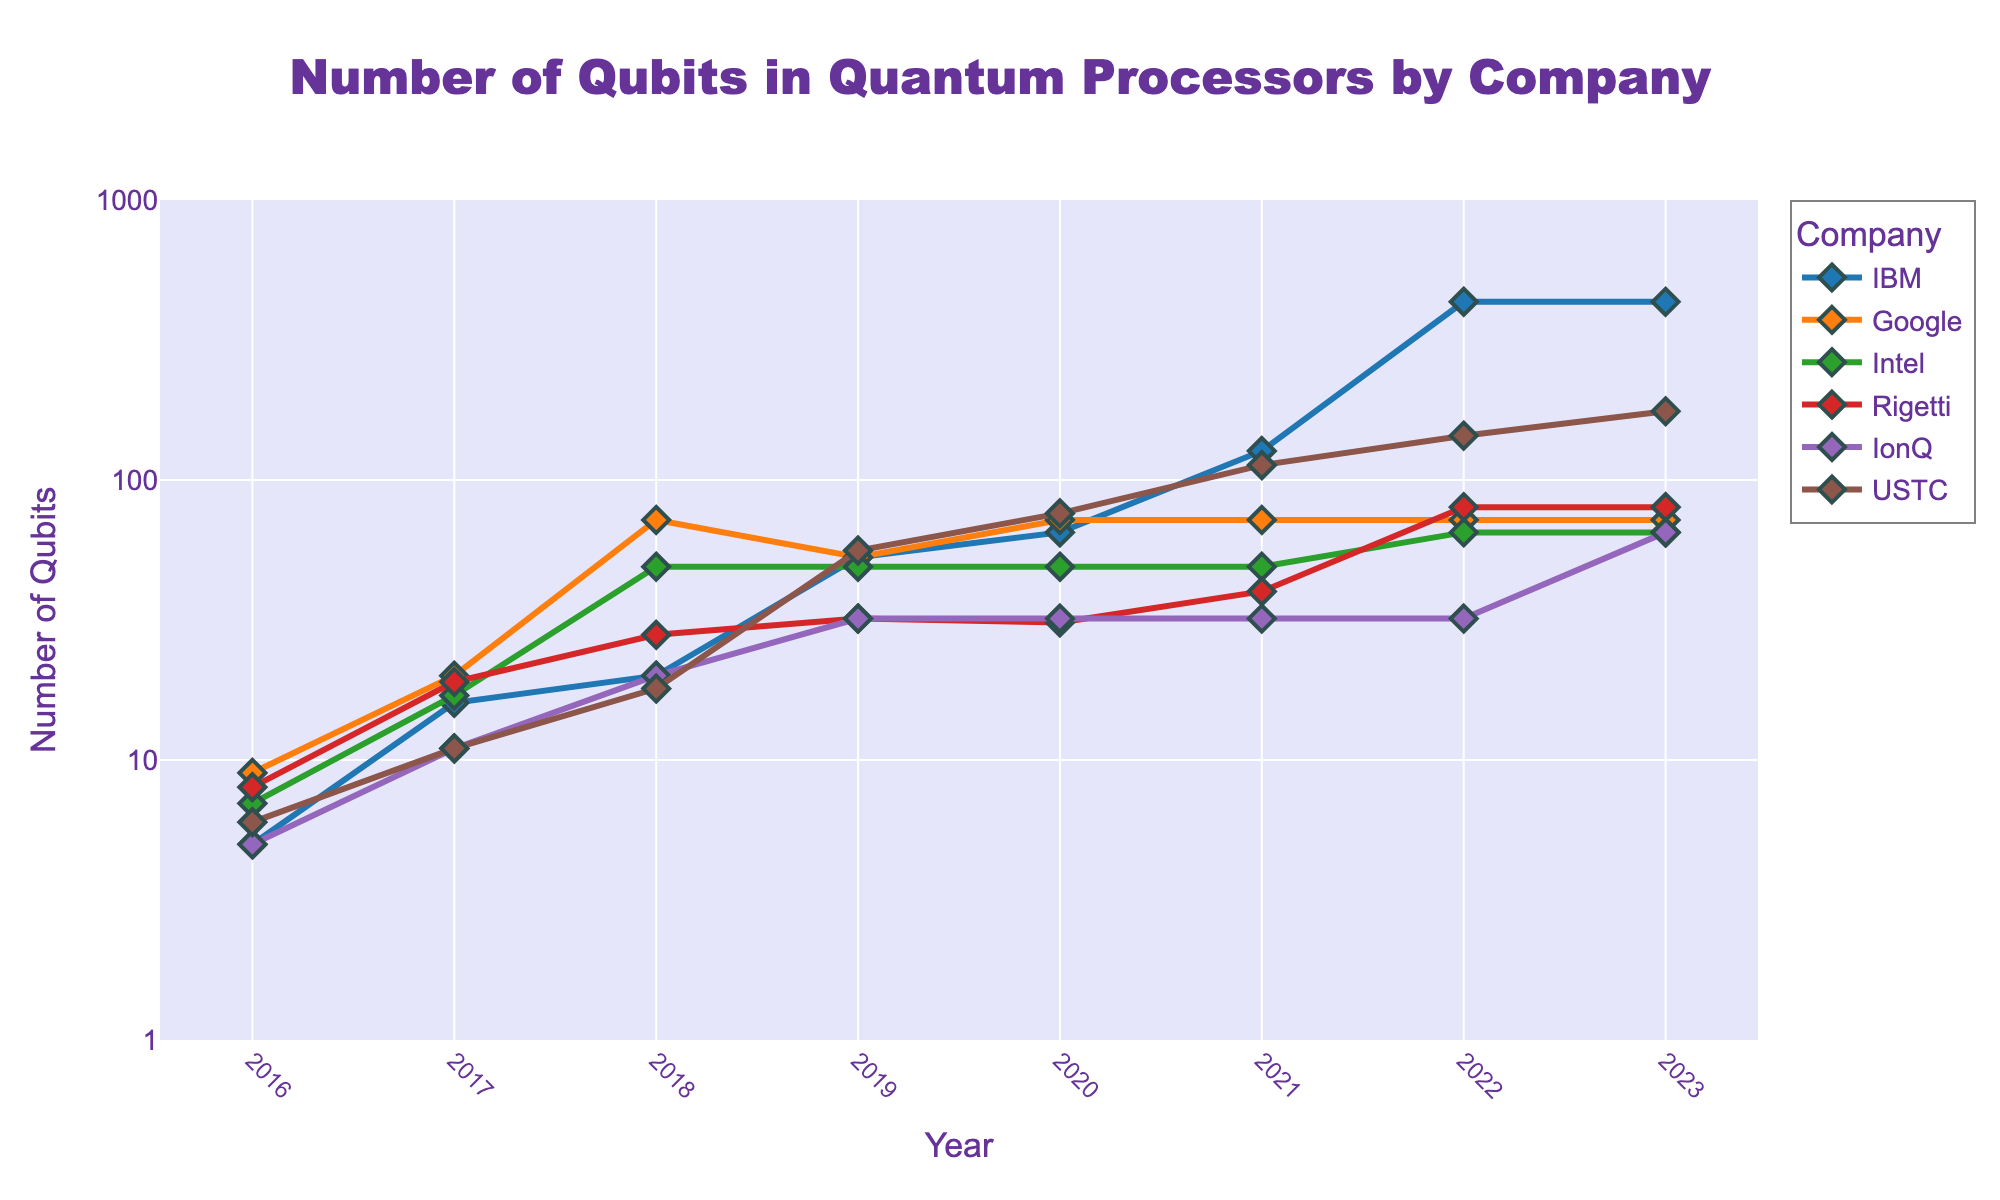Which company showed the highest increase in the number of qubits from 2016 to 2023? To determine the highest increase, subtract the 2016 value from the 2023 value for each company. IBM: 433-5=428, Google: 72-9=63, Intel: 65-7=58, Rigetti: 80-8=72, IonQ: 65-5=60, USTC: 176-6=170. IBM shows the highest increase.
Answer: IBM Which company maintained a constant number of qubits for the longest period? Examine the chart for each company and identify the lines that remain constant without increasing or decreasing. Google has a constant number of qubits (72) from 2018 to 2023.
Answer: Google In which year did USTC surpass IBM in the number of qubits for the first time? Review the figure and compare the number of qubits for USTC and IBM year by year. In 2019, USTC had 56 qubits, and IBM had 53 qubits.
Answer: 2019 How does the trend of Google's qubits differ from that of IBM's qubits? Google's qubit count increased sharply from 2017 to 2018 and then remained constant at 72, whereas IBM's count continuously increased over the years, with sharp jumps in 2017 and 2021.
Answer: Google shows an early sharp increase followed by constant values; IBM shows continuous growth with significant increases Which company had the highest number of qubits in 2022? Look at the data points for each company in 2022 and find the highest value. IBM had 433 qubits in 2022.
Answer: IBM What is the average number of qubits for IonQ across all years? Sum the number of qubits for IonQ across all years and divide by the number of years. (5+11+20+32+32+32+32+65) / 8 = 229/8 = 28.625
Answer: 28.625 Which two companies had the same number of qubits in 2019? Compare the qubit values for each company in 2019 and find which ones are equal. IBM and Google both had 53 qubits in 2019.
Answer: IBM and Google What is the overall pattern of qubits for Rigetti? Describe the line and data points for Rigetti across the years. Rigetti shows a general upwards trend with an increase every year except a slight decrease in 2020.
Answer: Increasing with a slight dip in 2020 By how many qubits did Intel’s qubits increase from 2016 to 2022? Subtract the 2016 value from the 2022 value for Intel. 65 - 7 = 58.
Answer: 58 For which year and company is the lowest number of qubits recorded? Identify the smallest data point on the chart and find the corresponding year and company. The lowest recorded value is for IBM in 2016 at 5 qubits.
Answer: IBM in 2016 